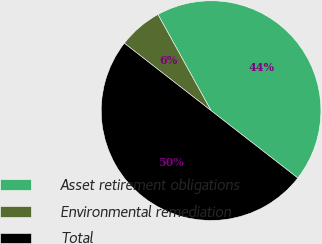Convert chart. <chart><loc_0><loc_0><loc_500><loc_500><pie_chart><fcel>Asset retirement obligations<fcel>Environmental remediation<fcel>Total<nl><fcel>43.55%<fcel>6.45%<fcel>50.0%<nl></chart> 